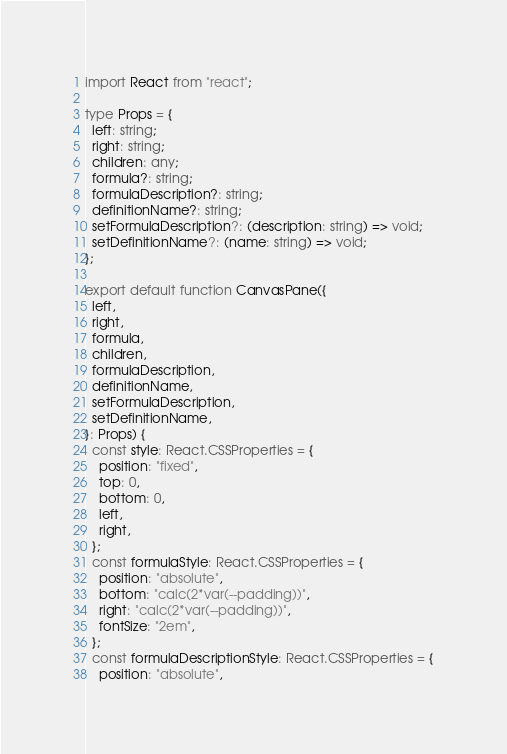<code> <loc_0><loc_0><loc_500><loc_500><_TypeScript_>import React from "react";

type Props = {
  left: string;
  right: string;
  children: any;
  formula?: string;
  formulaDescription?: string;
  definitionName?: string;
  setFormulaDescription?: (description: string) => void;
  setDefinitionName?: (name: string) => void;
};

export default function CanvasPane({
  left,
  right,
  formula,
  children,
  formulaDescription,
  definitionName,
  setFormulaDescription,
  setDefinitionName,
}: Props) {
  const style: React.CSSProperties = {
    position: "fixed",
    top: 0,
    bottom: 0,
    left,
    right,
  };
  const formulaStyle: React.CSSProperties = {
    position: "absolute",
    bottom: "calc(2*var(--padding))",
    right: "calc(2*var(--padding))",
    fontSize: "2em",
  };
  const formulaDescriptionStyle: React.CSSProperties = {
    position: "absolute",</code> 